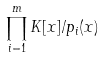Convert formula to latex. <formula><loc_0><loc_0><loc_500><loc_500>\prod _ { i = 1 } ^ { m } K [ x ] / p _ { i } ( x )</formula> 